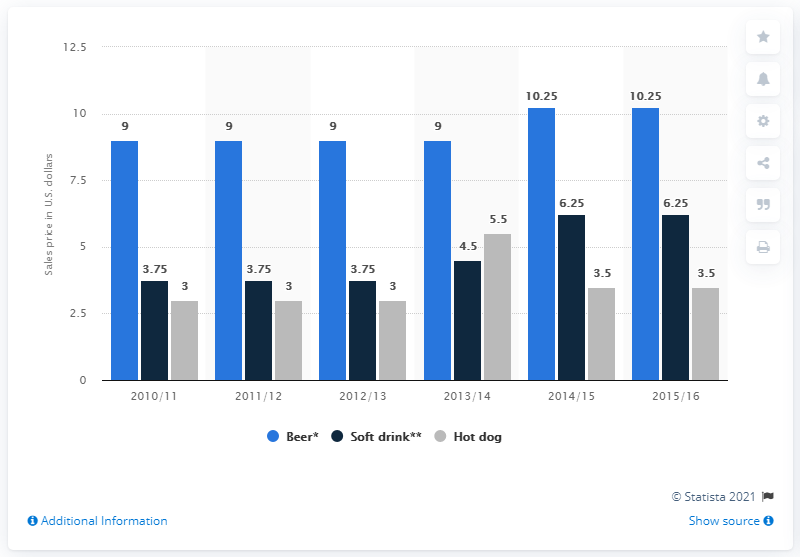Specify some key components in this picture. The maximum beer price exceeded the minimum hot dog price from 2010 to 2016 by 7.25 dollars. 